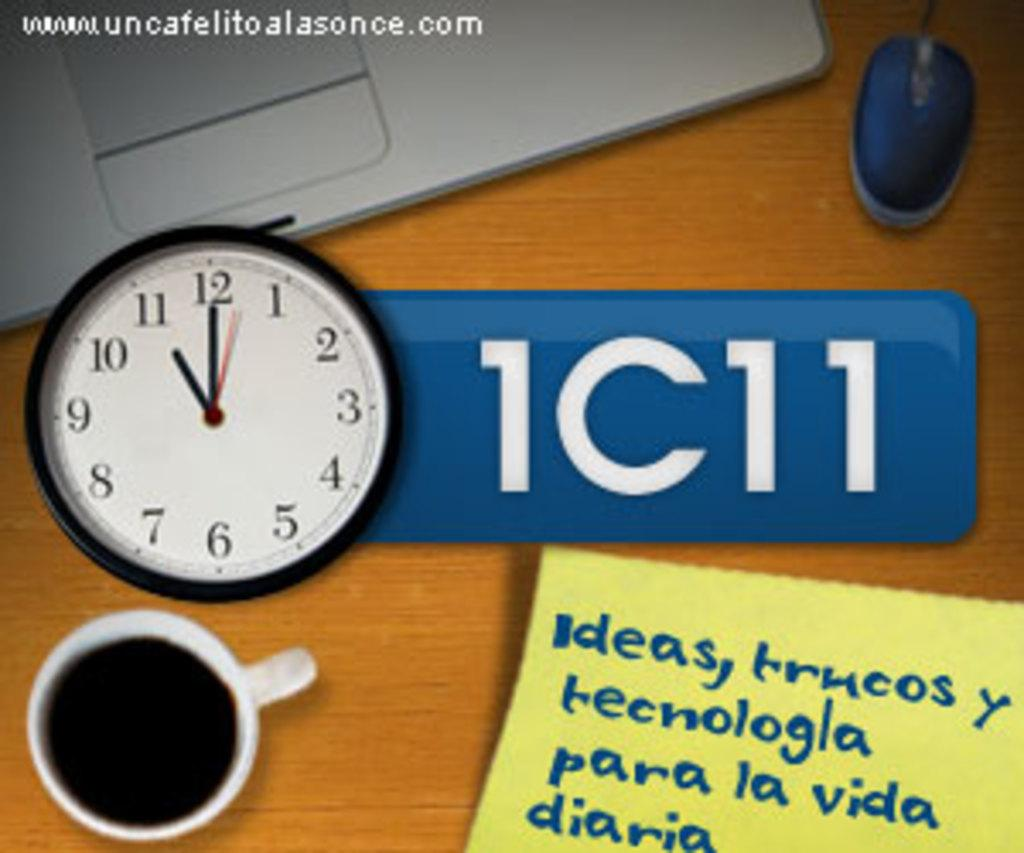<image>
Render a clear and concise summary of the photo. A clock that says 11:00, 1C11 and a website on the top that says www.uncafelitoalasonce.com. 